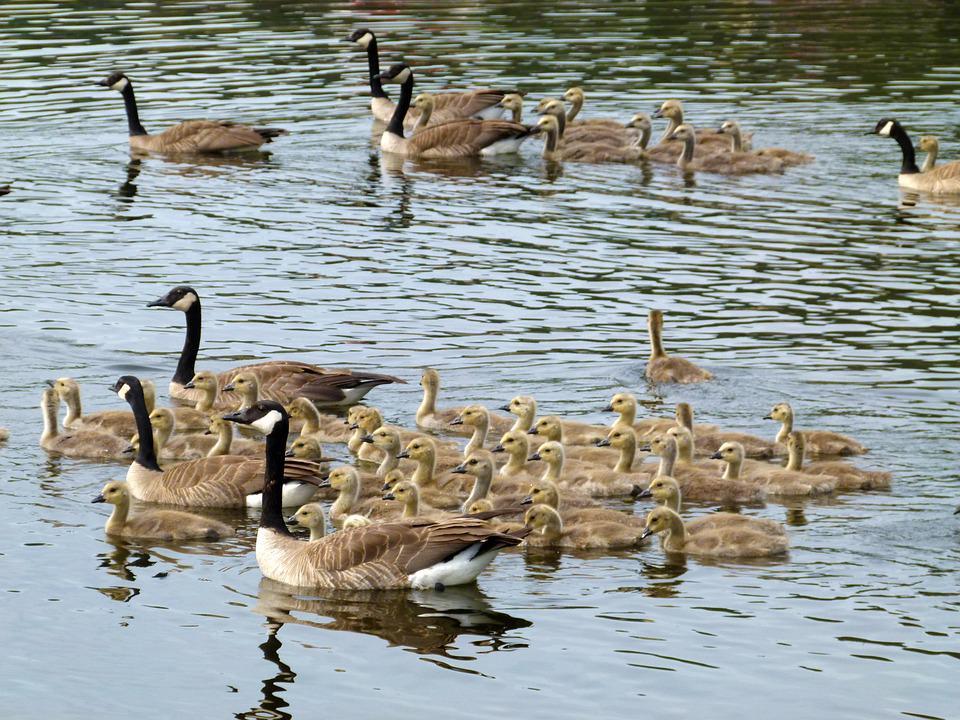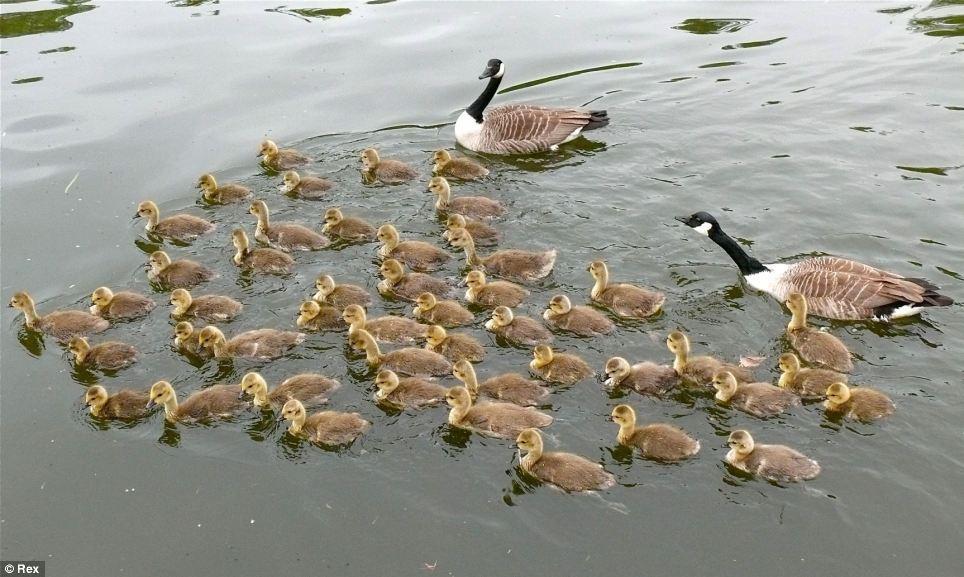The first image is the image on the left, the second image is the image on the right. Assess this claim about the two images: "The ducks in the left image are all facing towards the right.". Correct or not? Answer yes or no. No. The first image is the image on the left, the second image is the image on the right. Examine the images to the left and right. Is the description "There are two adult geese leading no more than seven ducking." accurate? Answer yes or no. No. 